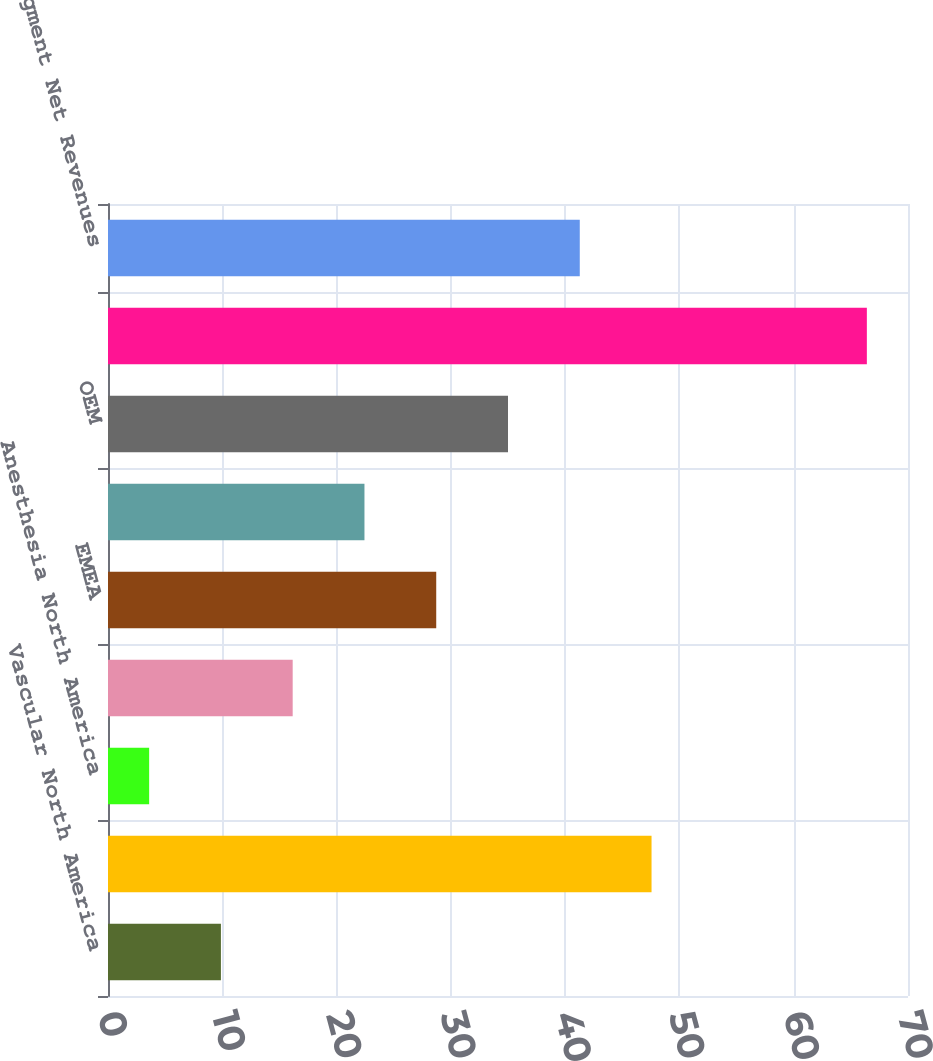Convert chart. <chart><loc_0><loc_0><loc_500><loc_500><bar_chart><fcel>Vascular North America<fcel>Interventional North America<fcel>Anesthesia North America<fcel>Surgical North America<fcel>EMEA<fcel>Asia<fcel>OEM<fcel>All other<fcel>Segment Net Revenues<nl><fcel>9.88<fcel>47.56<fcel>3.6<fcel>16.16<fcel>28.72<fcel>22.44<fcel>35<fcel>66.4<fcel>41.28<nl></chart> 